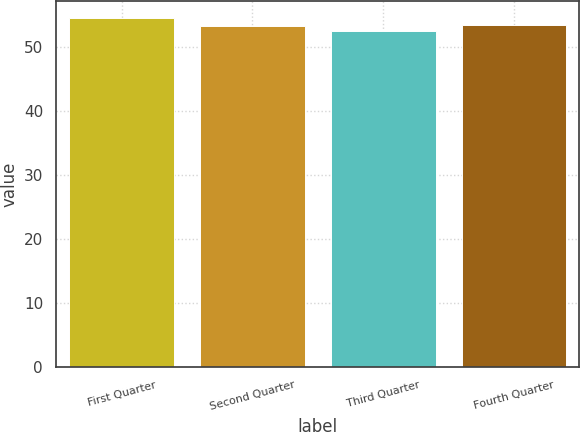Convert chart to OTSL. <chart><loc_0><loc_0><loc_500><loc_500><bar_chart><fcel>First Quarter<fcel>Second Quarter<fcel>Third Quarter<fcel>Fourth Quarter<nl><fcel>54.55<fcel>53.39<fcel>52.5<fcel>53.59<nl></chart> 